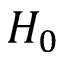<formula> <loc_0><loc_0><loc_500><loc_500>H _ { 0 }</formula> 